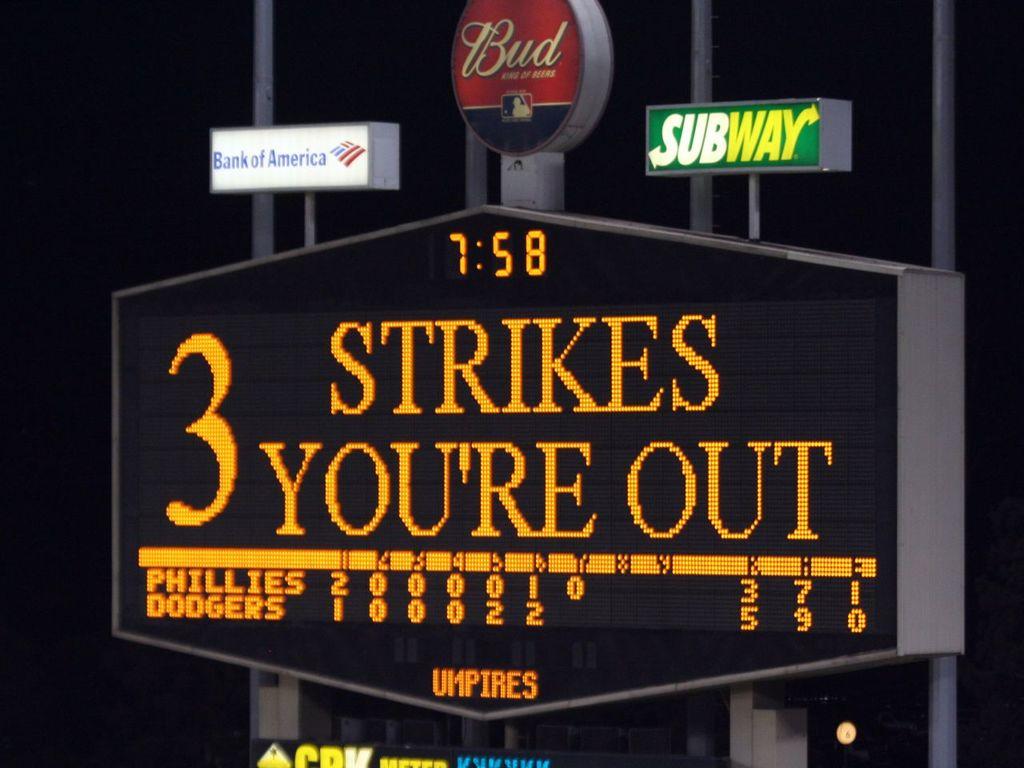What brand is displayed on the top red banner?
Ensure brevity in your answer.  Bud. Which bank is a sponsor at the baseball stadium?
Provide a short and direct response. Bank of america. 